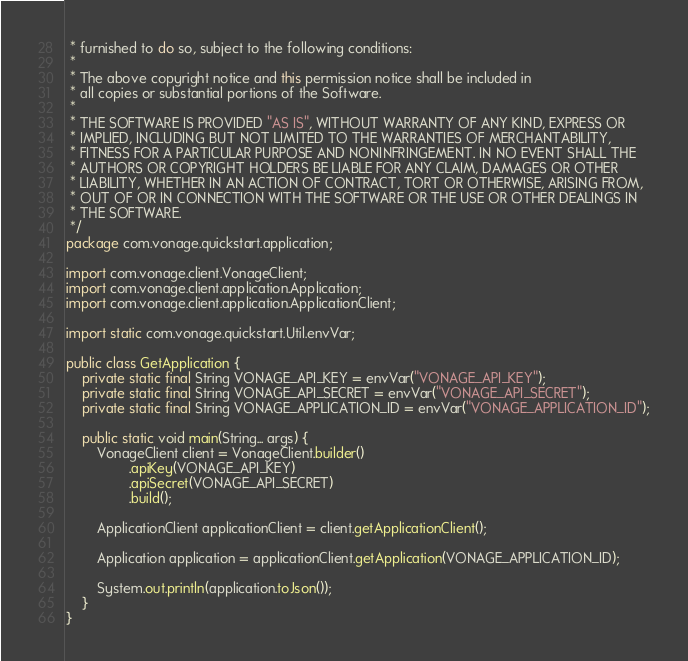Convert code to text. <code><loc_0><loc_0><loc_500><loc_500><_Java_> * furnished to do so, subject to the following conditions:
 *
 * The above copyright notice and this permission notice shall be included in
 * all copies or substantial portions of the Software.
 *
 * THE SOFTWARE IS PROVIDED "AS IS", WITHOUT WARRANTY OF ANY KIND, EXPRESS OR
 * IMPLIED, INCLUDING BUT NOT LIMITED TO THE WARRANTIES OF MERCHANTABILITY,
 * FITNESS FOR A PARTICULAR PURPOSE AND NONINFRINGEMENT. IN NO EVENT SHALL THE
 * AUTHORS OR COPYRIGHT HOLDERS BE LIABLE FOR ANY CLAIM, DAMAGES OR OTHER
 * LIABILITY, WHETHER IN AN ACTION OF CONTRACT, TORT OR OTHERWISE, ARISING FROM,
 * OUT OF OR IN CONNECTION WITH THE SOFTWARE OR THE USE OR OTHER DEALINGS IN
 * THE SOFTWARE.
 */
package com.vonage.quickstart.application;

import com.vonage.client.VonageClient;
import com.vonage.client.application.Application;
import com.vonage.client.application.ApplicationClient;

import static com.vonage.quickstart.Util.envVar;

public class GetApplication {
    private static final String VONAGE_API_KEY = envVar("VONAGE_API_KEY");
    private static final String VONAGE_API_SECRET = envVar("VONAGE_API_SECRET");
    private static final String VONAGE_APPLICATION_ID = envVar("VONAGE_APPLICATION_ID");

    public static void main(String... args) {
        VonageClient client = VonageClient.builder()
                .apiKey(VONAGE_API_KEY)
                .apiSecret(VONAGE_API_SECRET)
                .build();

        ApplicationClient applicationClient = client.getApplicationClient();

        Application application = applicationClient.getApplication(VONAGE_APPLICATION_ID);

        System.out.println(application.toJson());
    }
}
</code> 